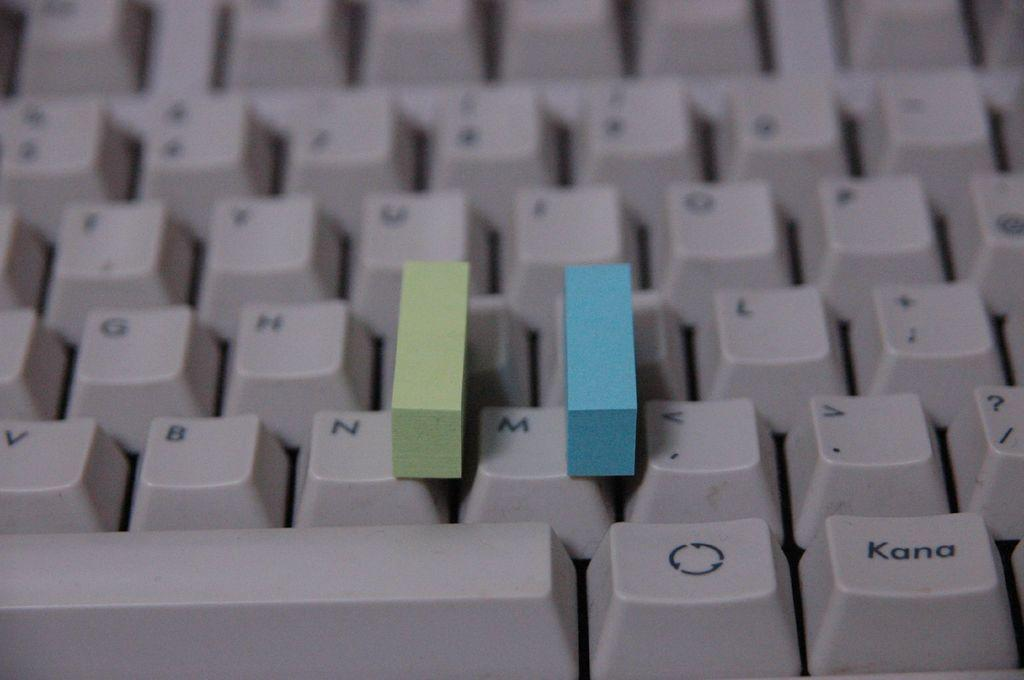<image>
Offer a succinct explanation of the picture presented. A green and a blue block are set on a keyboard that includes a Kana button. 